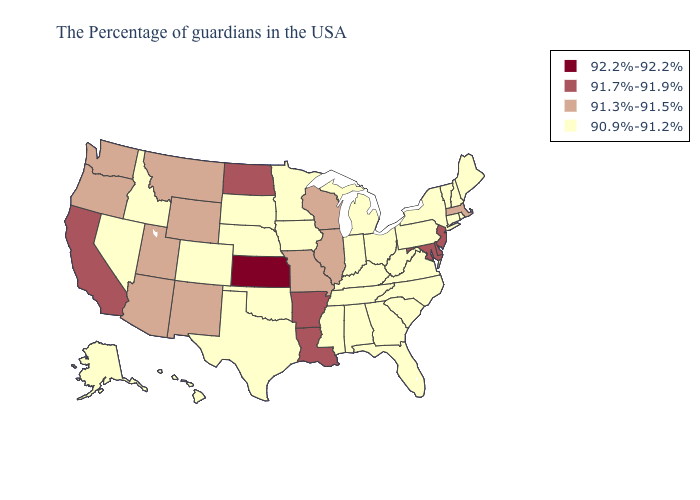Is the legend a continuous bar?
Short answer required. No. What is the lowest value in the South?
Write a very short answer. 90.9%-91.2%. Name the states that have a value in the range 92.2%-92.2%?
Keep it brief. Kansas. Name the states that have a value in the range 90.9%-91.2%?
Keep it brief. Maine, Rhode Island, New Hampshire, Vermont, Connecticut, New York, Pennsylvania, Virginia, North Carolina, South Carolina, West Virginia, Ohio, Florida, Georgia, Michigan, Kentucky, Indiana, Alabama, Tennessee, Mississippi, Minnesota, Iowa, Nebraska, Oklahoma, Texas, South Dakota, Colorado, Idaho, Nevada, Alaska, Hawaii. What is the value of Mississippi?
Keep it brief. 90.9%-91.2%. Name the states that have a value in the range 91.7%-91.9%?
Quick response, please. New Jersey, Delaware, Maryland, Louisiana, Arkansas, North Dakota, California. Among the states that border Massachusetts , which have the highest value?
Keep it brief. Rhode Island, New Hampshire, Vermont, Connecticut, New York. Does Georgia have a higher value than Delaware?
Short answer required. No. How many symbols are there in the legend?
Concise answer only. 4. Name the states that have a value in the range 92.2%-92.2%?
Be succinct. Kansas. Which states have the lowest value in the Northeast?
Keep it brief. Maine, Rhode Island, New Hampshire, Vermont, Connecticut, New York, Pennsylvania. Does Mississippi have the lowest value in the USA?
Answer briefly. Yes. What is the value of Kentucky?
Be succinct. 90.9%-91.2%. 